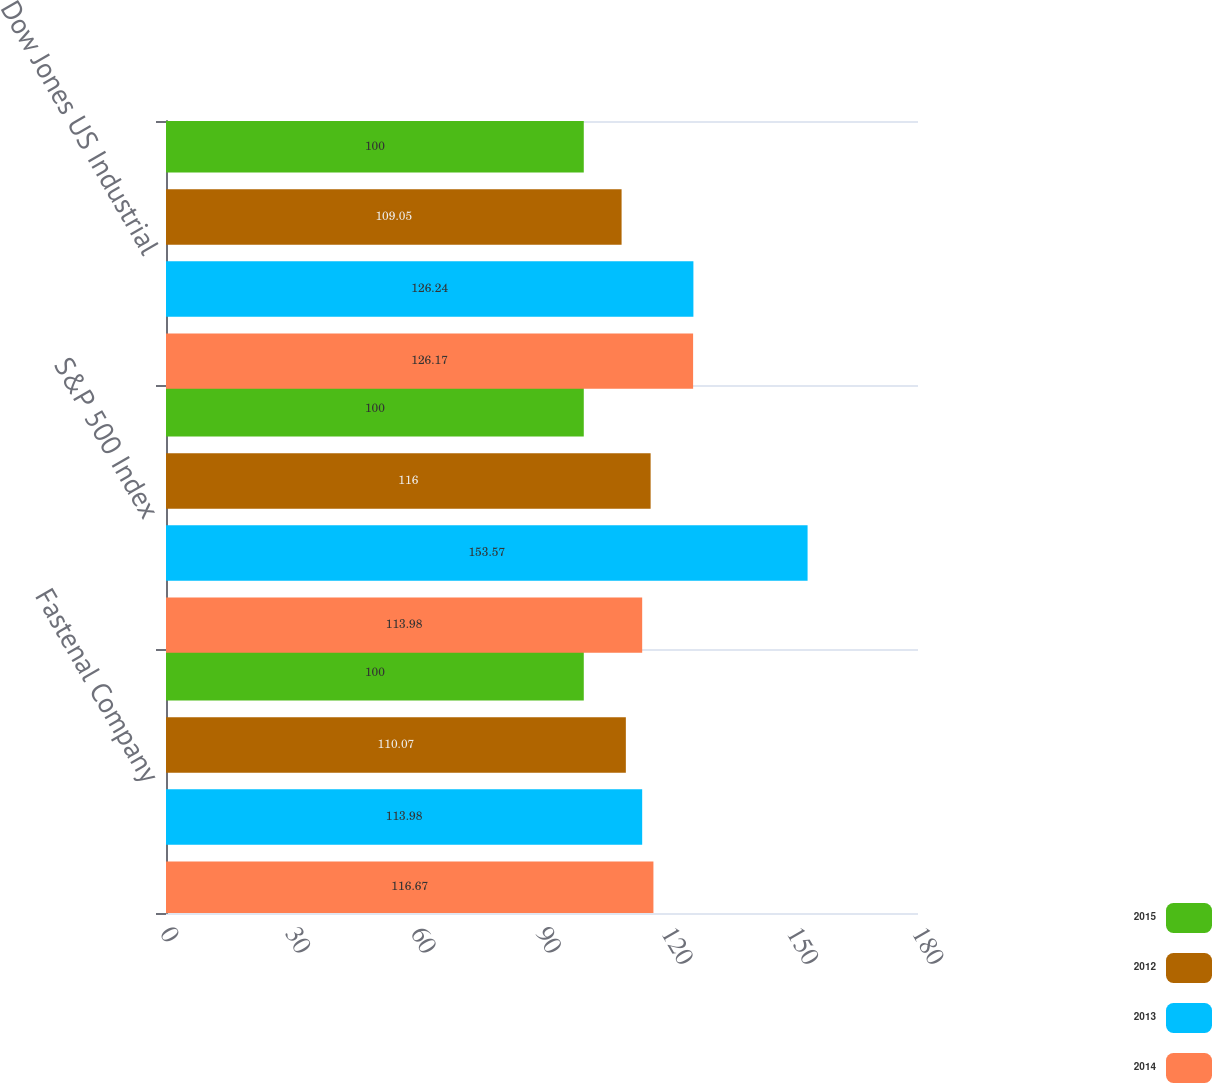<chart> <loc_0><loc_0><loc_500><loc_500><stacked_bar_chart><ecel><fcel>Fastenal Company<fcel>S&P 500 Index<fcel>Dow Jones US Industrial<nl><fcel>2015<fcel>100<fcel>100<fcel>100<nl><fcel>2012<fcel>110.07<fcel>116<fcel>109.05<nl><fcel>2013<fcel>113.98<fcel>153.57<fcel>126.24<nl><fcel>2014<fcel>116.67<fcel>113.98<fcel>126.17<nl></chart> 